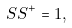Convert formula to latex. <formula><loc_0><loc_0><loc_500><loc_500>S S ^ { + } = 1 ,</formula> 